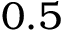<formula> <loc_0><loc_0><loc_500><loc_500>0 . 5</formula> 